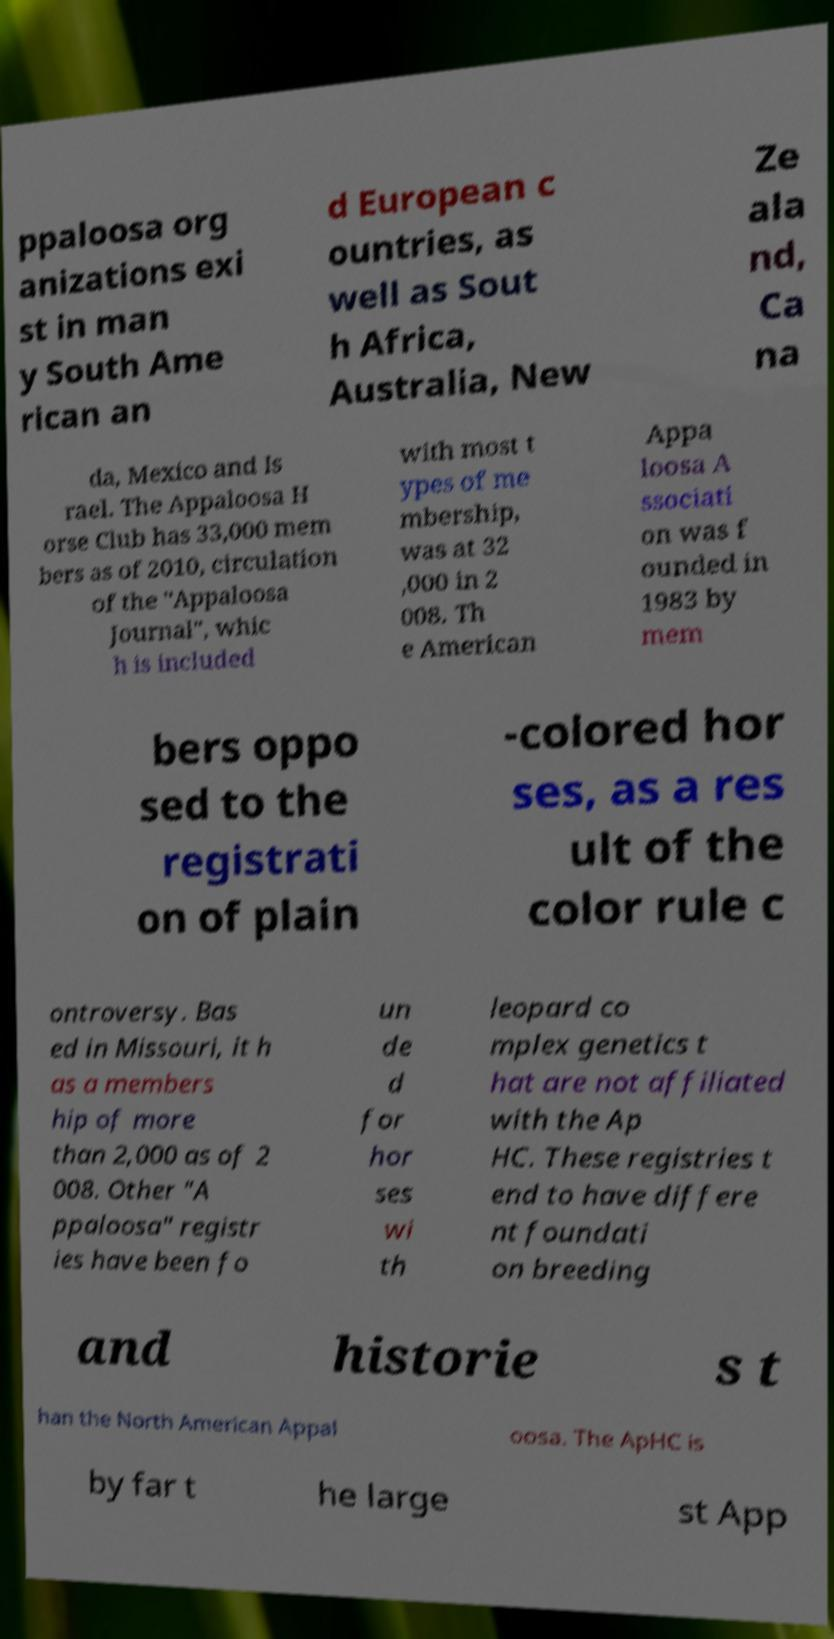Can you accurately transcribe the text from the provided image for me? ppaloosa org anizations exi st in man y South Ame rican an d European c ountries, as well as Sout h Africa, Australia, New Ze ala nd, Ca na da, Mexico and Is rael. The Appaloosa H orse Club has 33,000 mem bers as of 2010, circulation of the "Appaloosa Journal", whic h is included with most t ypes of me mbership, was at 32 ,000 in 2 008. Th e American Appa loosa A ssociati on was f ounded in 1983 by mem bers oppo sed to the registrati on of plain -colored hor ses, as a res ult of the color rule c ontroversy. Bas ed in Missouri, it h as a members hip of more than 2,000 as of 2 008. Other "A ppaloosa" registr ies have been fo un de d for hor ses wi th leopard co mplex genetics t hat are not affiliated with the Ap HC. These registries t end to have differe nt foundati on breeding and historie s t han the North American Appal oosa. The ApHC is by far t he large st App 